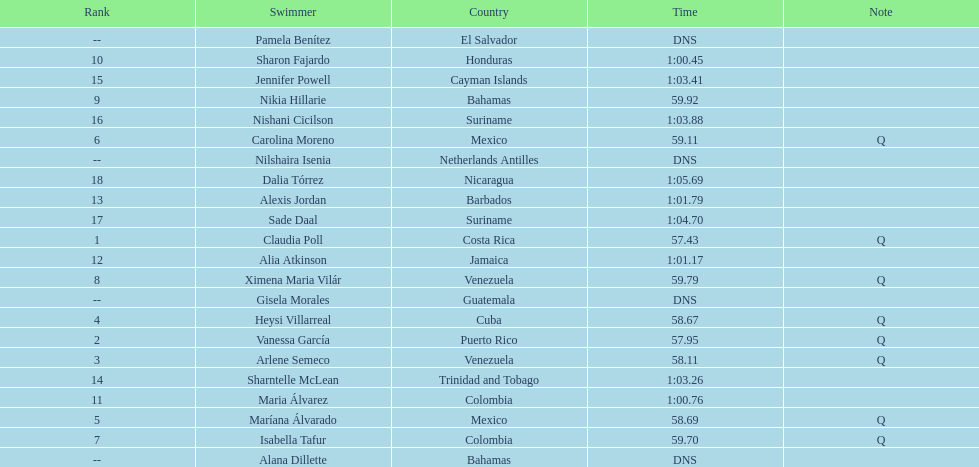Which swimmer had the longest time? Dalia Tórrez. 